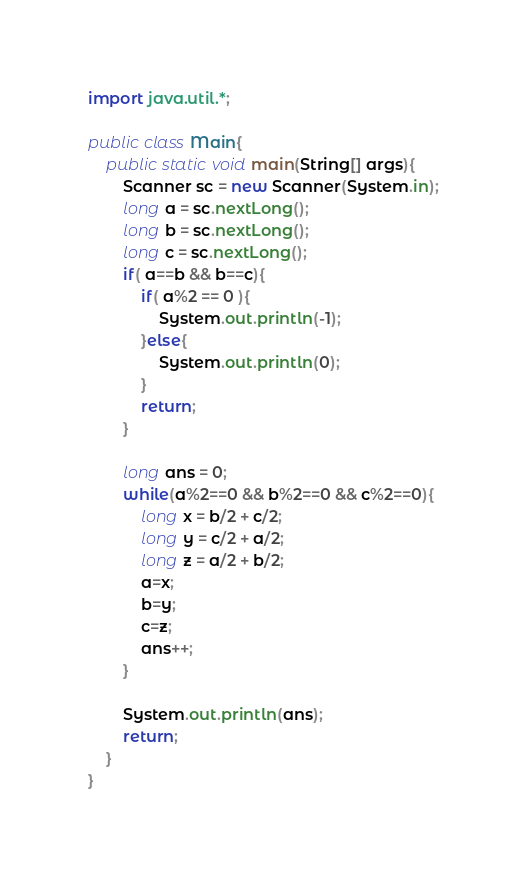<code> <loc_0><loc_0><loc_500><loc_500><_Java_>import java.util.*;
 
public class Main{
	public static void main(String[] args){
		Scanner sc = new Scanner(System.in);
		long a = sc.nextLong();
		long b = sc.nextLong();
		long c = sc.nextLong();
		if( a==b && b==c){
			if( a%2 == 0 ){
				System.out.println(-1);
			}else{
				System.out.println(0);
			}
			return;
		}
		
		long ans = 0;
		while(a%2==0 && b%2==0 && c%2==0){
			long x = b/2 + c/2;
			long y = c/2 + a/2;
			long z = a/2 + b/2;
			a=x;
			b=y;
			c=z;
			ans++;
		}
		
		System.out.println(ans);
		return;
	}
}</code> 